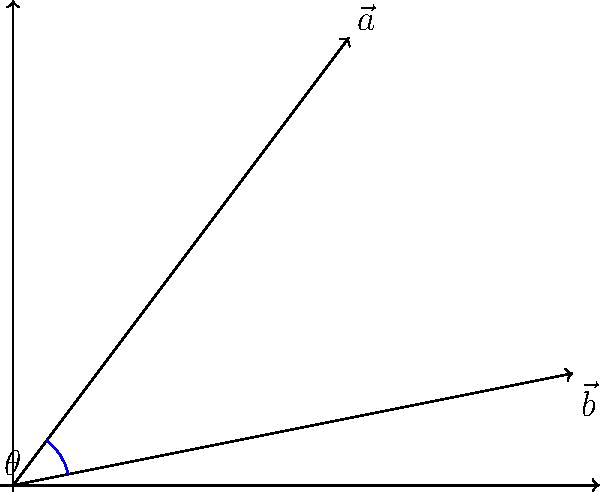In image processing, gradients are often represented as vectors. Given two gradient vectors $\vec{a} = (3, 4)$ and $\vec{b} = (5, 1)$, calculate the angle $\theta$ between them. Express your answer in degrees, rounded to the nearest integer. To find the angle between two vectors, we can use the dot product formula:

$$\cos \theta = \frac{\vec{a} \cdot \vec{b}}{|\vec{a}||\vec{b}|}$$

Step 1: Calculate the dot product $\vec{a} \cdot \vec{b}$
$$\vec{a} \cdot \vec{b} = (3 \times 5) + (4 \times 1) = 15 + 4 = 19$$

Step 2: Calculate the magnitudes of the vectors
$$|\vec{a}| = \sqrt{3^2 + 4^2} = \sqrt{9 + 16} = \sqrt{25} = 5$$
$$|\vec{b}| = \sqrt{5^2 + 1^2} = \sqrt{25 + 1} = \sqrt{26}$$

Step 3: Apply the dot product formula
$$\cos \theta = \frac{19}{5\sqrt{26}}$$

Step 4: Take the inverse cosine (arccos) of both sides
$$\theta = \arccos\left(\frac{19}{5\sqrt{26}}\right)$$

Step 5: Convert to degrees and round to the nearest integer
$$\theta \approx 44.42^\circ \approx 44^\circ$$
Answer: 44° 